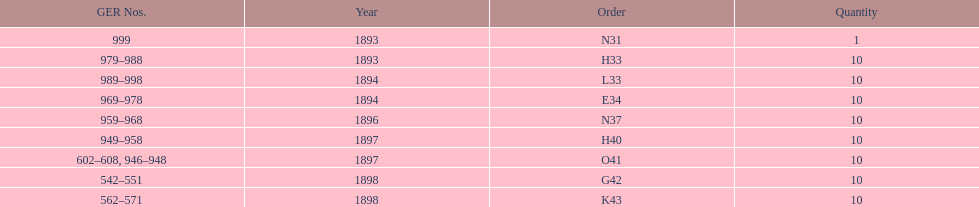What amount of time to the years span? 5 years. 